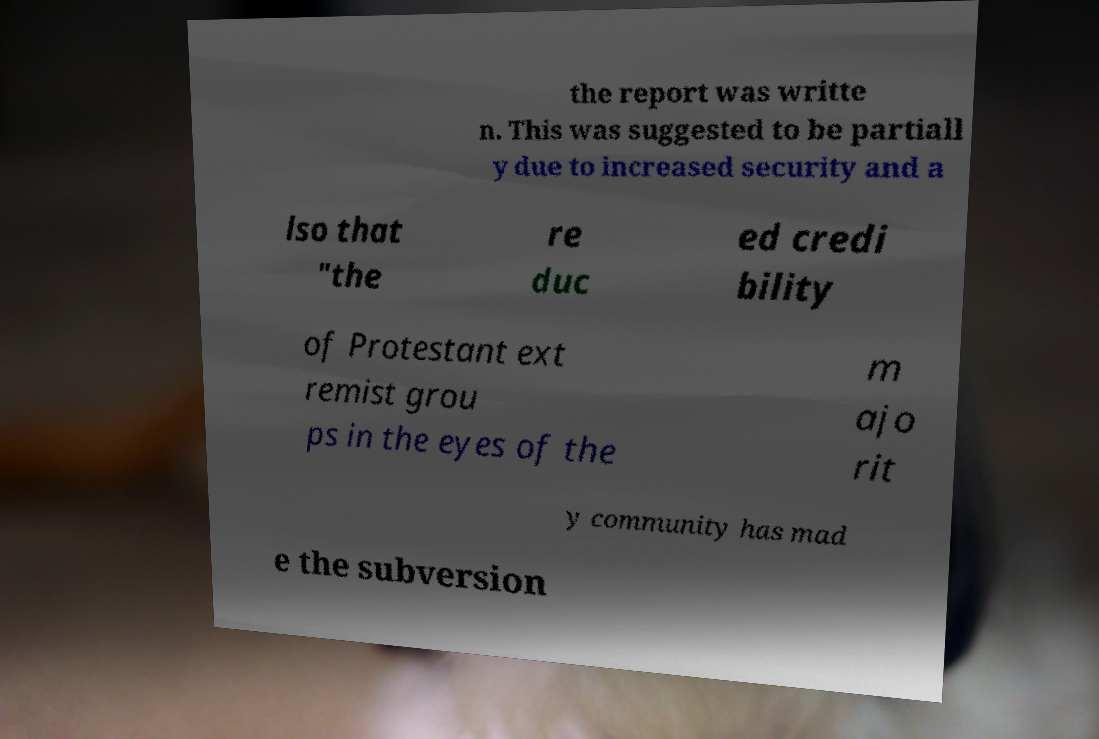Please identify and transcribe the text found in this image. the report was writte n. This was suggested to be partiall y due to increased security and a lso that "the re duc ed credi bility of Protestant ext remist grou ps in the eyes of the m ajo rit y community has mad e the subversion 